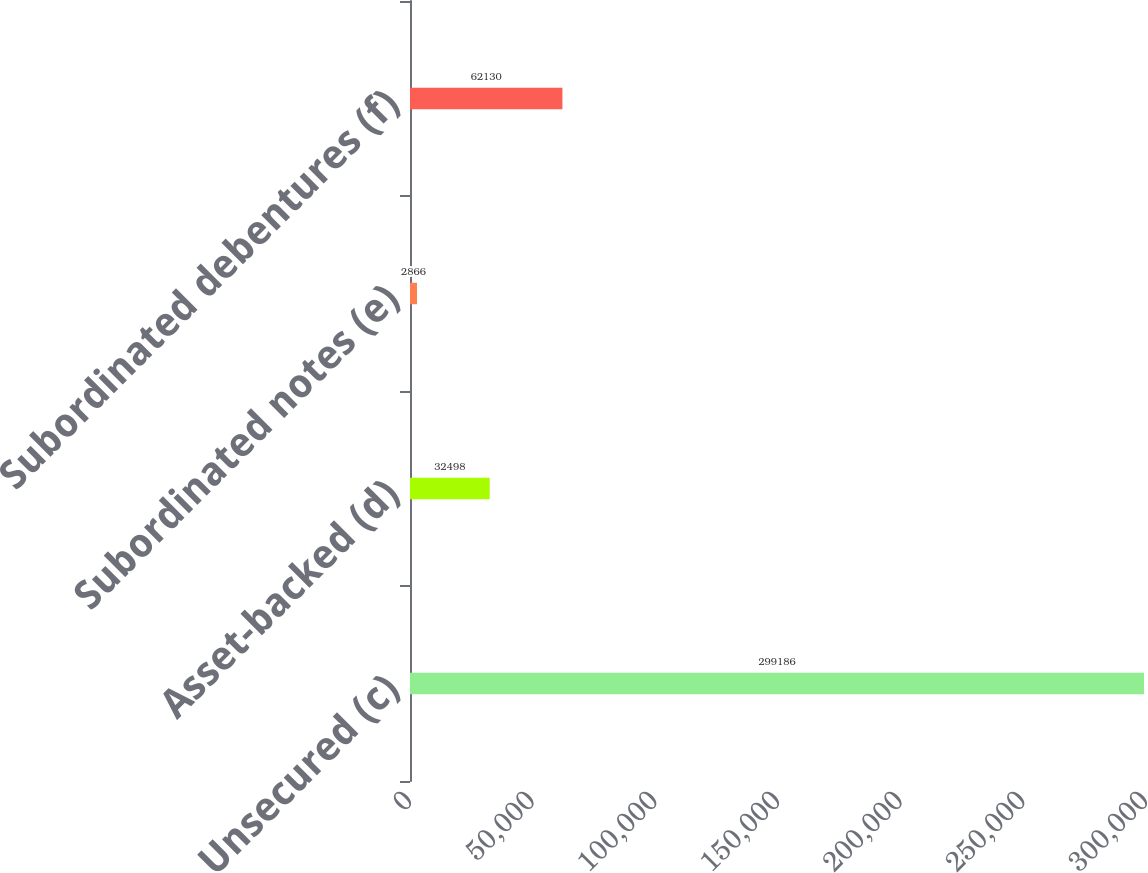Convert chart to OTSL. <chart><loc_0><loc_0><loc_500><loc_500><bar_chart><fcel>Unsecured (c)<fcel>Asset-backed (d)<fcel>Subordinated notes (e)<fcel>Subordinated debentures (f)<nl><fcel>299186<fcel>32498<fcel>2866<fcel>62130<nl></chart> 